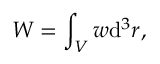Convert formula to latex. <formula><loc_0><loc_0><loc_500><loc_500>W = \int _ { V } w d ^ { 3 } r ,</formula> 